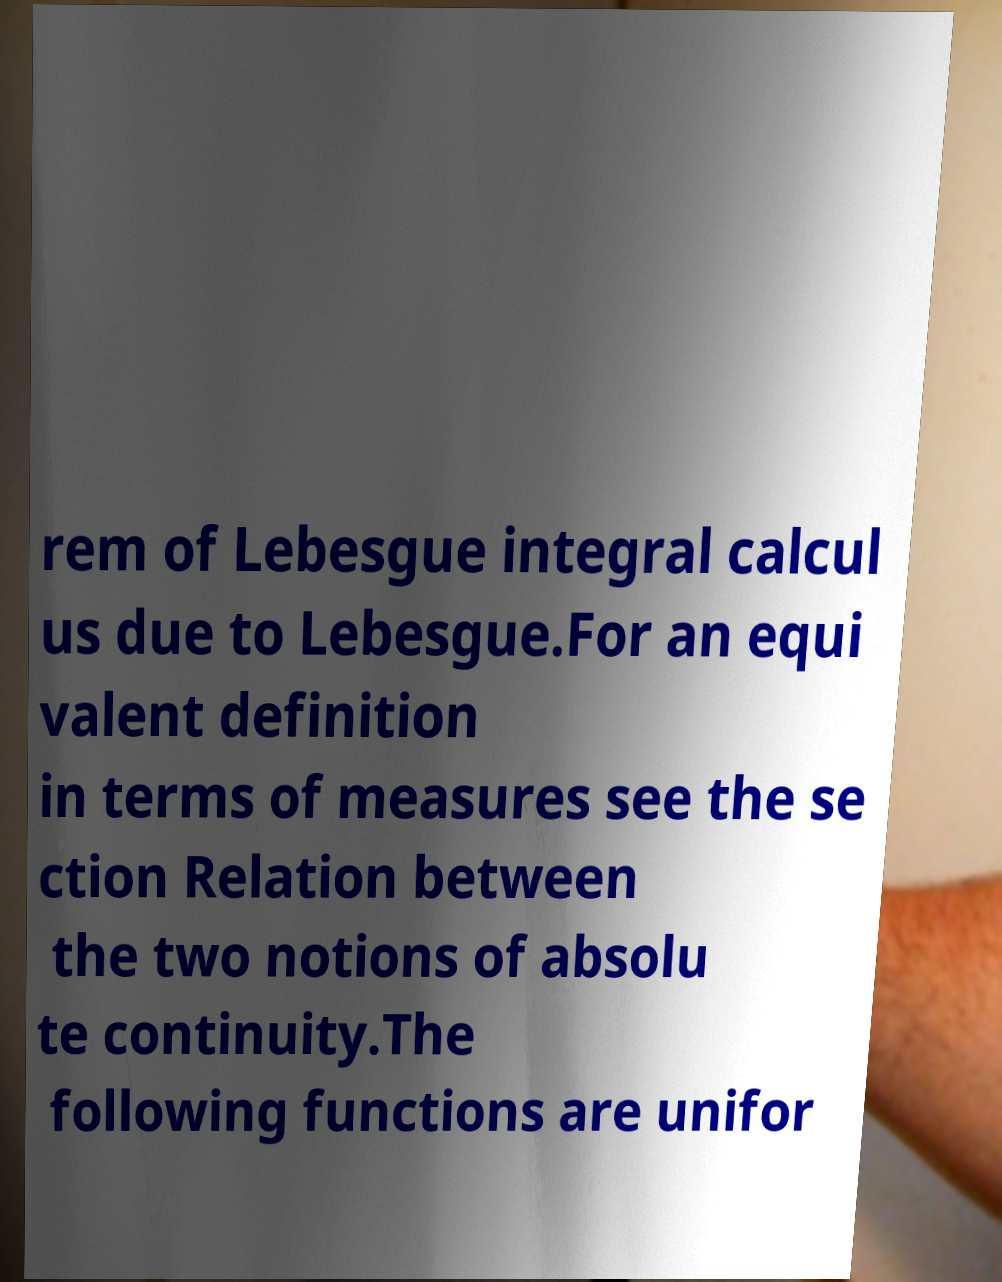Can you read and provide the text displayed in the image?This photo seems to have some interesting text. Can you extract and type it out for me? rem of Lebesgue integral calcul us due to Lebesgue.For an equi valent definition in terms of measures see the se ction Relation between the two notions of absolu te continuity.The following functions are unifor 